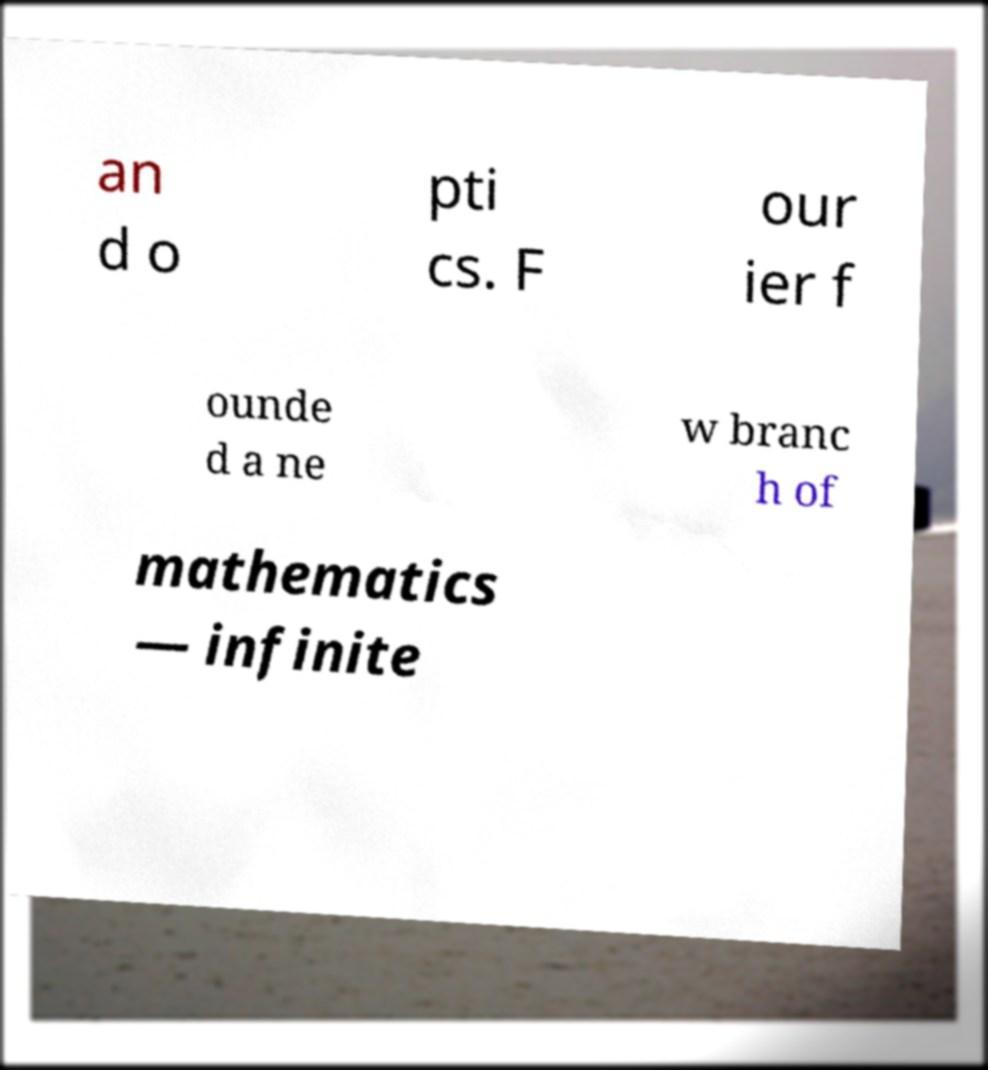Could you assist in decoding the text presented in this image and type it out clearly? an d o pti cs. F our ier f ounde d a ne w branc h of mathematics — infinite 